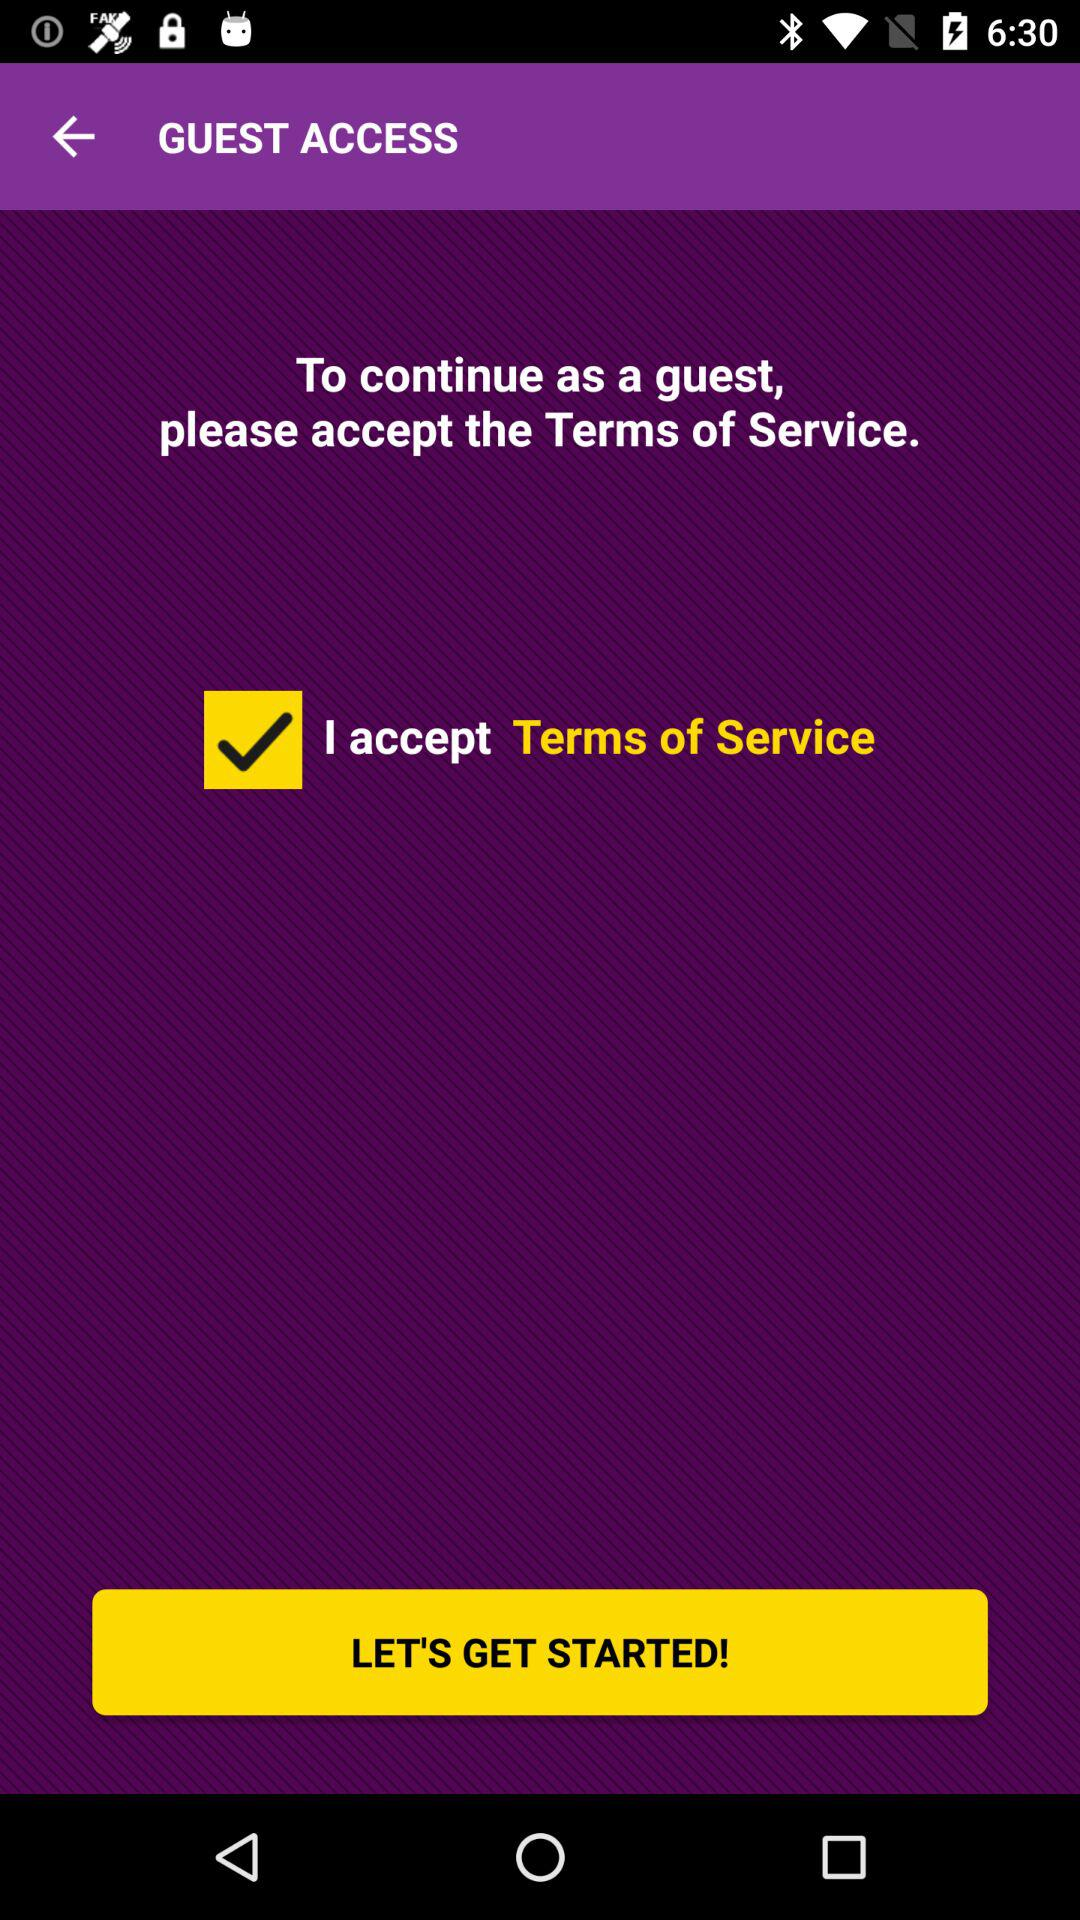What is the current status of the "I accept Terms of Service"? The current status is "on". 